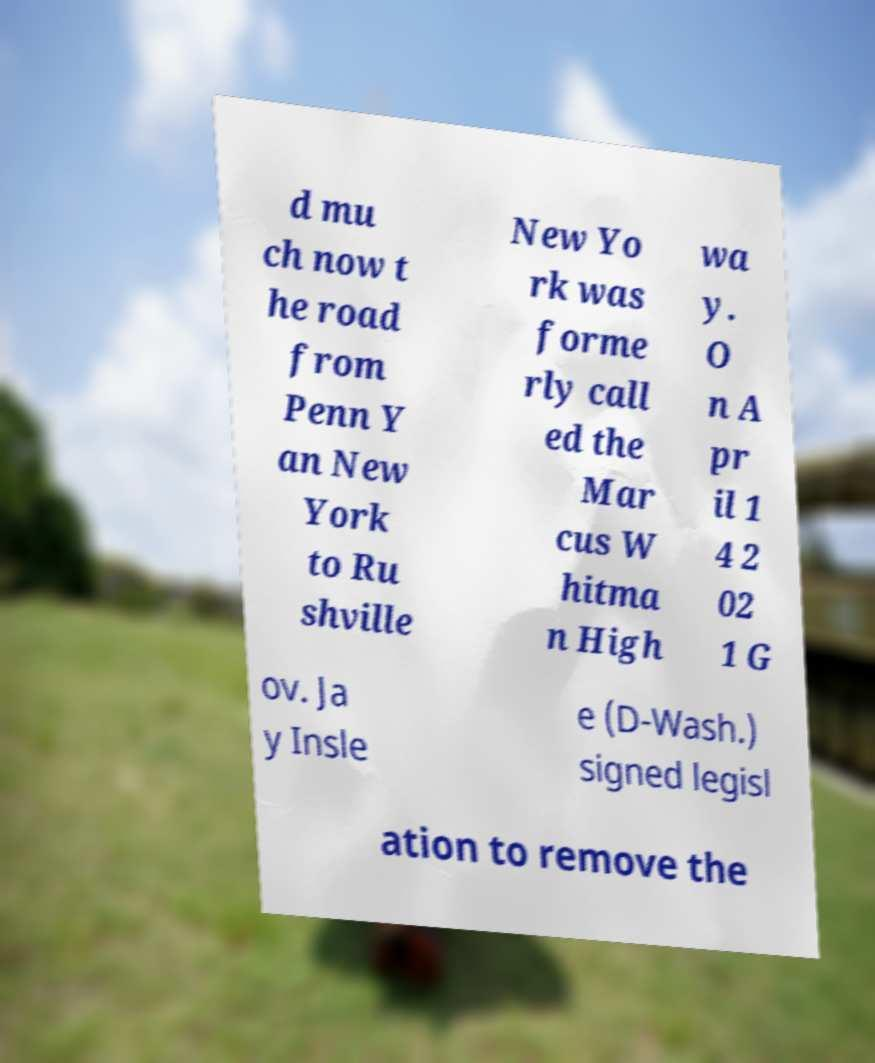Can you read and provide the text displayed in the image?This photo seems to have some interesting text. Can you extract and type it out for me? d mu ch now t he road from Penn Y an New York to Ru shville New Yo rk was forme rly call ed the Mar cus W hitma n High wa y. O n A pr il 1 4 2 02 1 G ov. Ja y Insle e (D-Wash.) signed legisl ation to remove the 